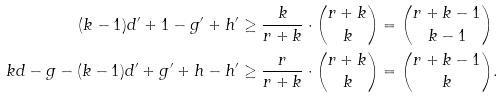Convert formula to latex. <formula><loc_0><loc_0><loc_500><loc_500>( k - 1 ) d ^ { \prime } + 1 - g ^ { \prime } + h ^ { \prime } & \geq \frac { k } { r + k } \cdot \binom { r + k } { k } = \binom { r + k - 1 } { k - 1 } \\ k d - g - ( k - 1 ) d ^ { \prime } + g ^ { \prime } + h - h ^ { \prime } & \geq \frac { r } { r + k } \cdot \binom { r + k } { k } = \binom { r + k - 1 } { k } .</formula> 